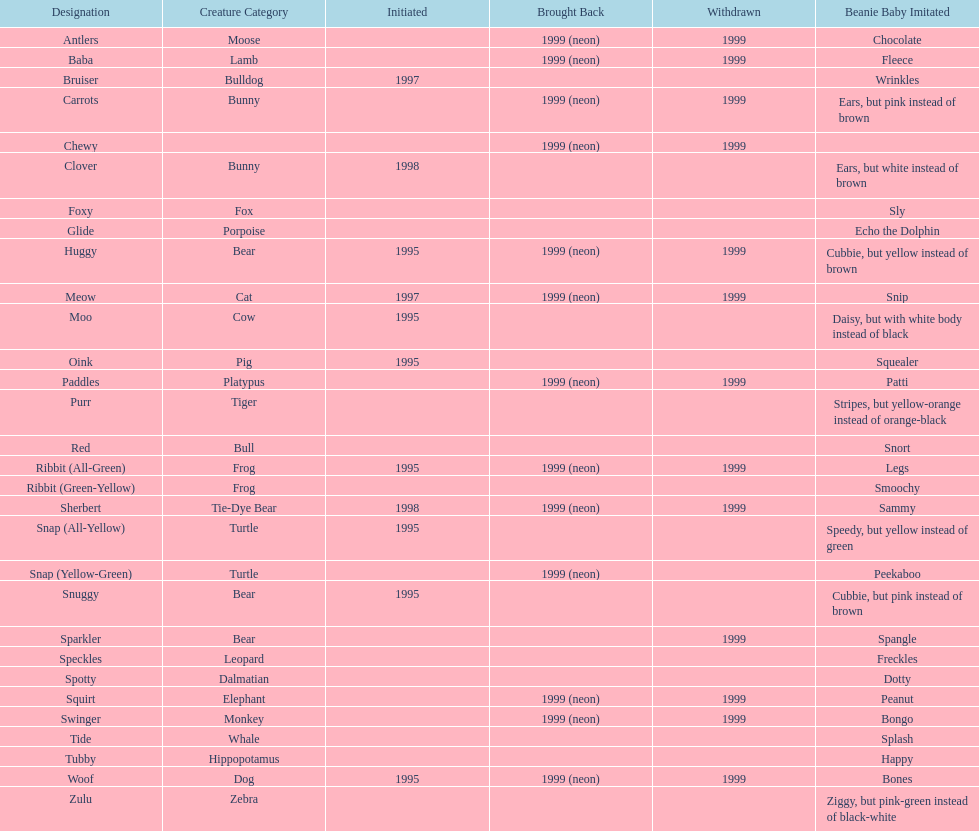Which animal type has the most pillow pals? Bear. 